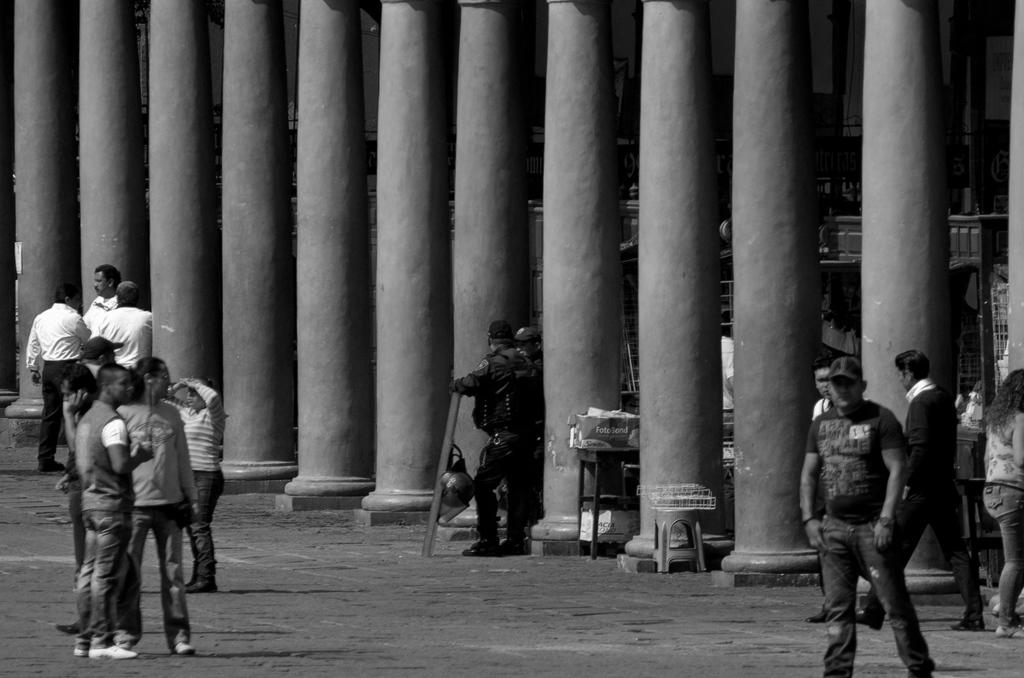Who or what can be seen in the image? There are people in the image. What architectural features are visible in the background? There are pillars in the background of the image. What type of chalk is being used by the dinosaurs in the image? There are no dinosaurs present in the image, so there is no chalk being used by them. 